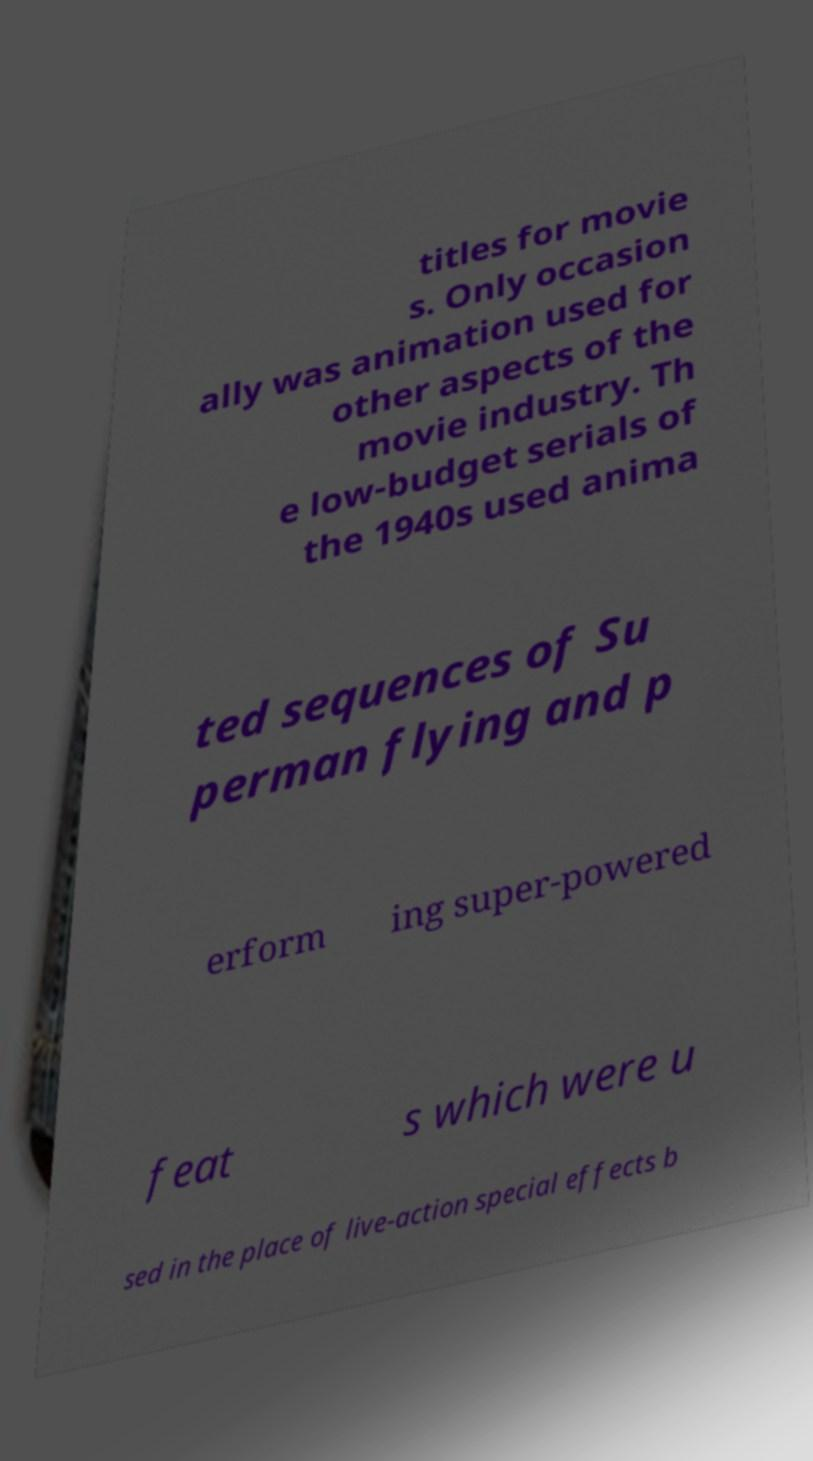Please identify and transcribe the text found in this image. titles for movie s. Only occasion ally was animation used for other aspects of the movie industry. Th e low-budget serials of the 1940s used anima ted sequences of Su perman flying and p erform ing super-powered feat s which were u sed in the place of live-action special effects b 